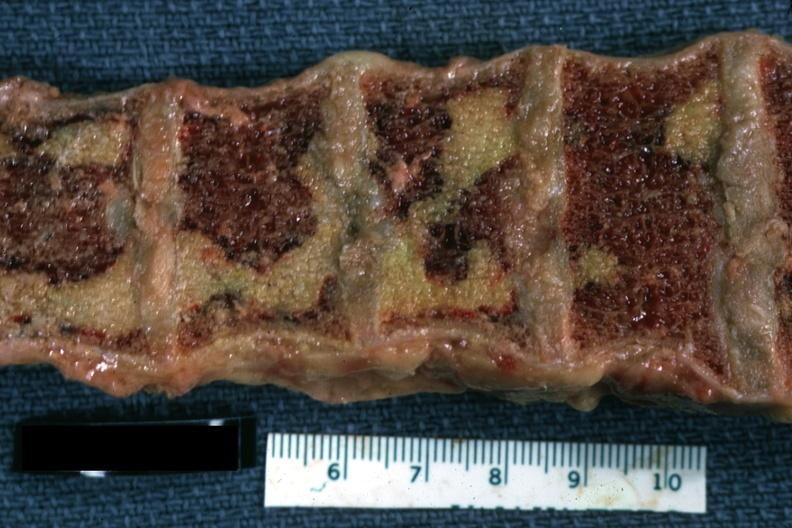what does this image show?
Answer the question using a single word or phrase. Close-up view of large areas of marrow necrosis case of chronic lymphocytic leukemia progressing to acute lymphocytic leukemia 